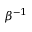<formula> <loc_0><loc_0><loc_500><loc_500>\beta ^ { - 1 }</formula> 